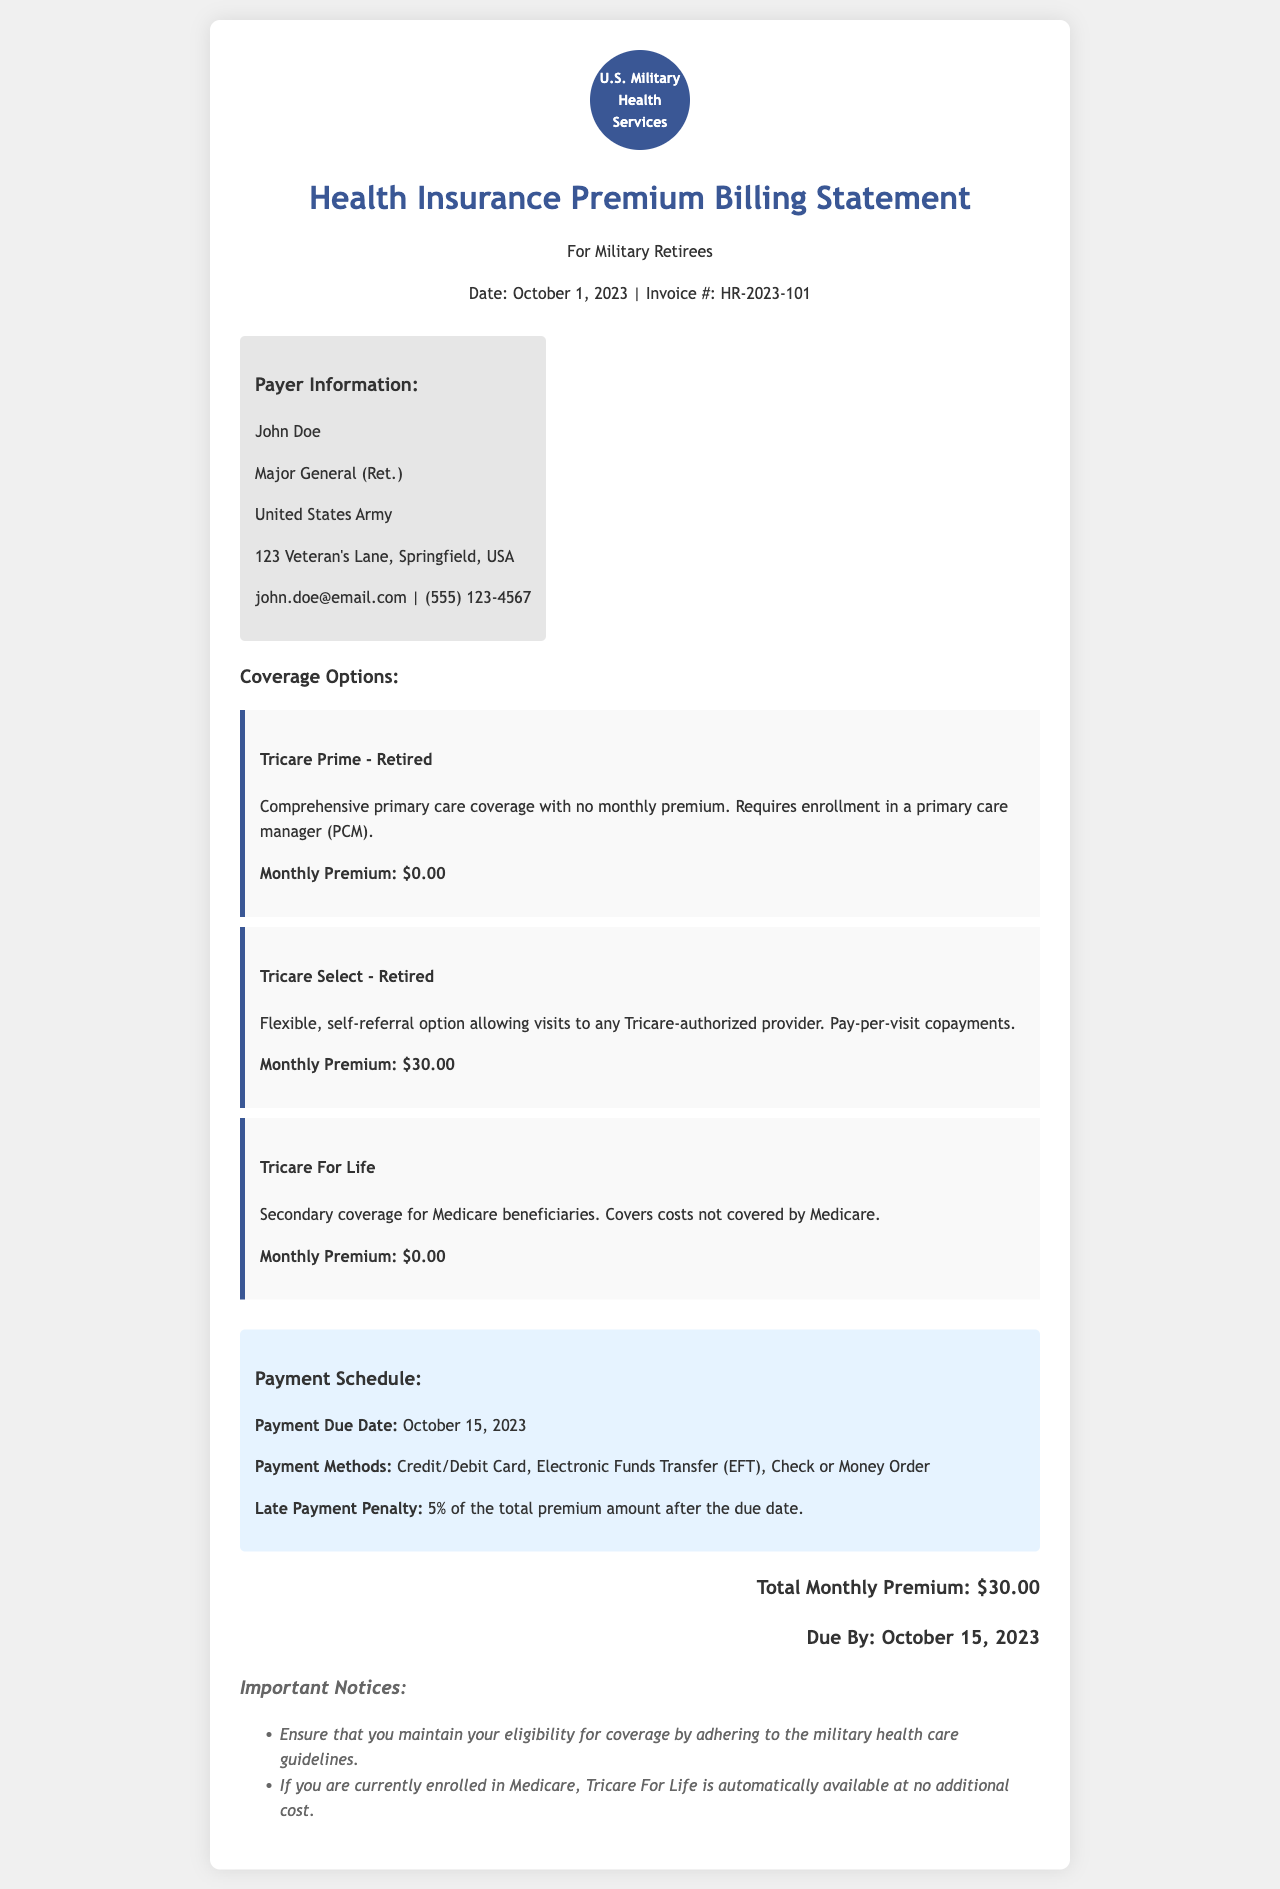What is the invoice number? The invoice number is specified in the document, which is HR-2023-101.
Answer: HR-2023-101 Who is the payer? The payer is listed in the document as John Doe.
Answer: John Doe What are the payment due date? The payment due date is given in the document as October 15, 2023.
Answer: October 15, 2023 What is the monthly premium for Tricare Select - Retired? The monthly premium for Tricare Select - Retired is specified as $30.00.
Answer: $30.00 What are the payment methods? The payment methods outlined in the document include Credit/Debit Card, Electronic Funds Transfer (EFT), Check or Money Order.
Answer: Credit/Debit Card, Electronic Funds Transfer (EFT), Check or Money Order What is the late payment penalty? The late payment penalty is stated as 5% of the total premium amount after the due date.
Answer: 5% What is the total monthly premium? The document specifies the total monthly premium as $30.00.
Answer: $30.00 How many coverage options are listed in the document? The document lists three coverage options for military retirees.
Answer: Three What is Tricare For Life? Tricare For Life is described in the document as secondary coverage for Medicare beneficiaries.
Answer: Secondary coverage for Medicare beneficiaries 